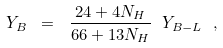Convert formula to latex. <formula><loc_0><loc_0><loc_500><loc_500>Y _ { B } \ = \ \frac { 2 4 + 4 N _ { H } } { 6 6 + 1 3 N _ { H } } \ Y _ { B - L } \ ,</formula> 